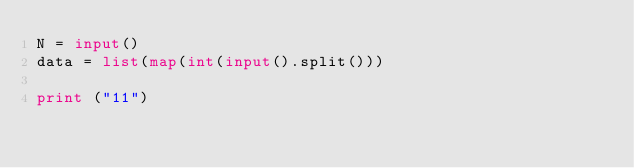<code> <loc_0><loc_0><loc_500><loc_500><_Python_>N = input()
data = list(map(int(input().split()))
            
print ("11")</code> 